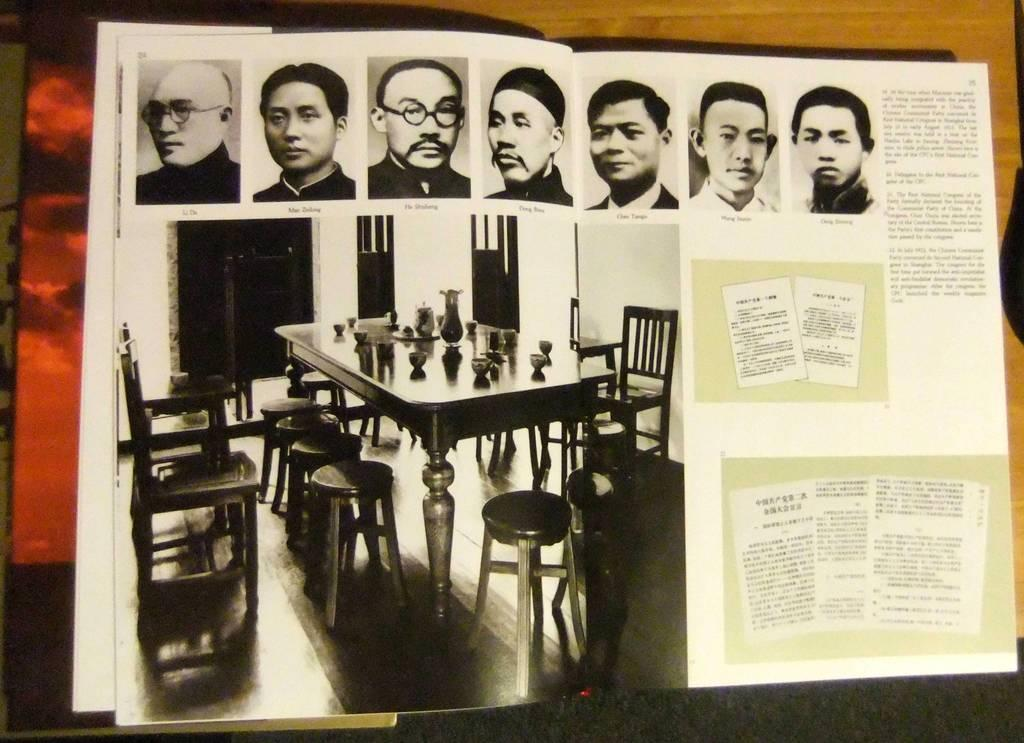What type of object is depicted in the image? The image appears to be a book or book-like object. Are there any furniture items visible in the image? Yes, there are chairs in the image. What type of table is present in the image? There is a dining table in the image. What can be seen in the top part of the image? There are images of men in the top part of the image. Where is the text located in the image? The text is on the right side of the image. How many visitors are swimming in the image? There are no visitors or swimming activities depicted in the image. What type of rail is present in the image? There is no rail present in the image. 